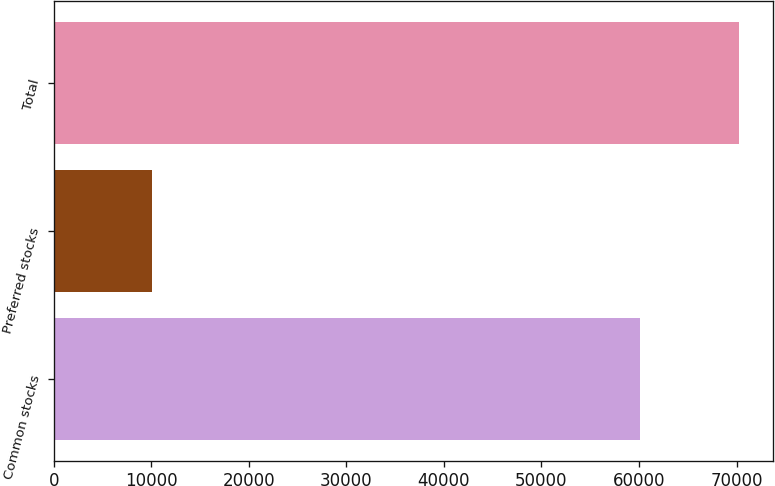Convert chart to OTSL. <chart><loc_0><loc_0><loc_500><loc_500><bar_chart><fcel>Common stocks<fcel>Preferred stocks<fcel>Total<nl><fcel>60102<fcel>10103<fcel>70205<nl></chart> 